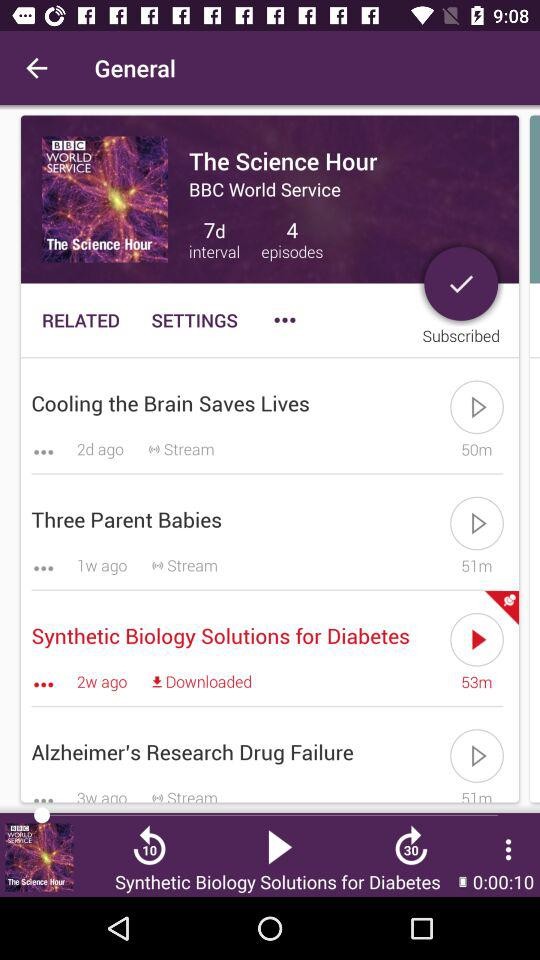Which episode was streamed a week ago? The episode was "Three Parent Babies". 